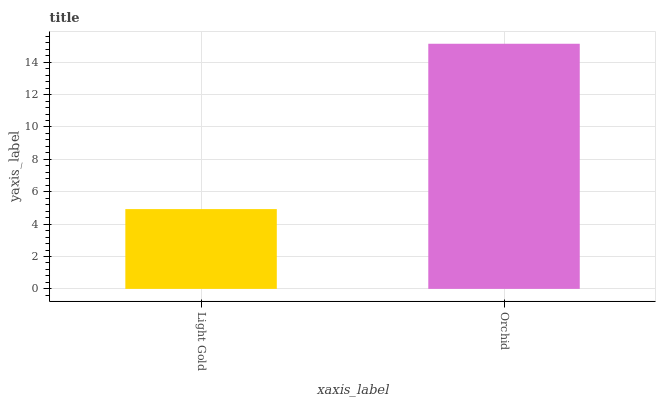Is Light Gold the minimum?
Answer yes or no. Yes. Is Orchid the maximum?
Answer yes or no. Yes. Is Orchid the minimum?
Answer yes or no. No. Is Orchid greater than Light Gold?
Answer yes or no. Yes. Is Light Gold less than Orchid?
Answer yes or no. Yes. Is Light Gold greater than Orchid?
Answer yes or no. No. Is Orchid less than Light Gold?
Answer yes or no. No. Is Orchid the high median?
Answer yes or no. Yes. Is Light Gold the low median?
Answer yes or no. Yes. Is Light Gold the high median?
Answer yes or no. No. Is Orchid the low median?
Answer yes or no. No. 